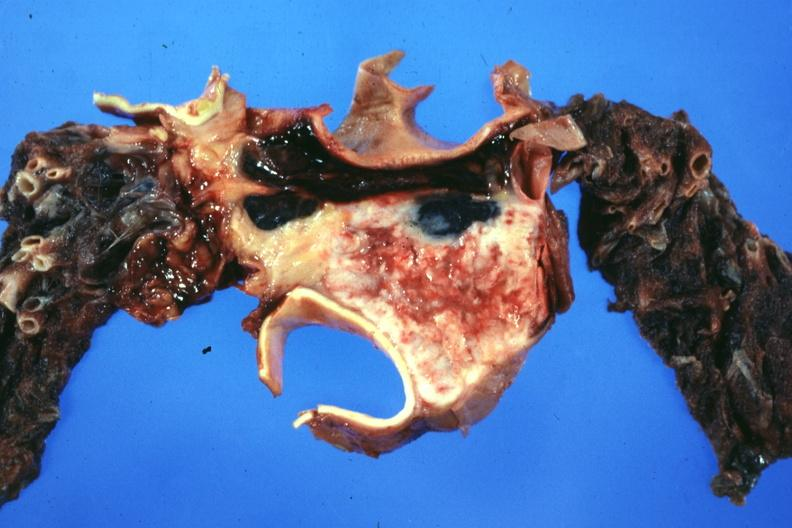what is present?
Answer the question using a single word or phrase. Malignant thymoma 